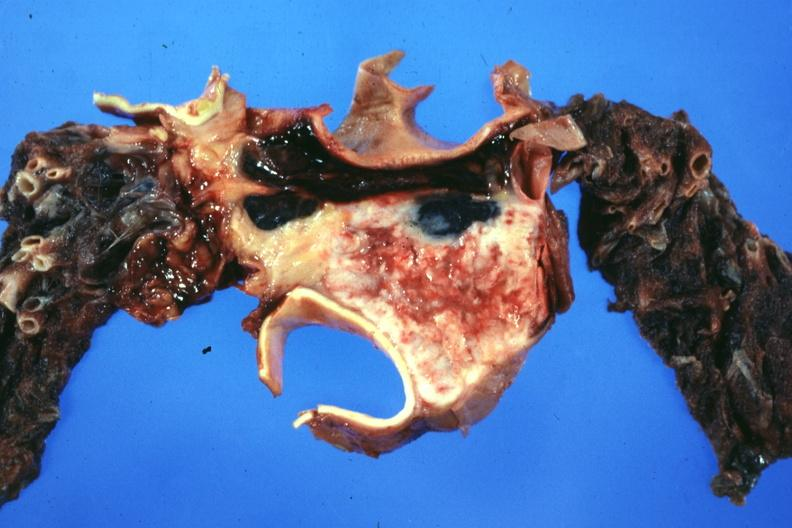what is present?
Answer the question using a single word or phrase. Malignant thymoma 